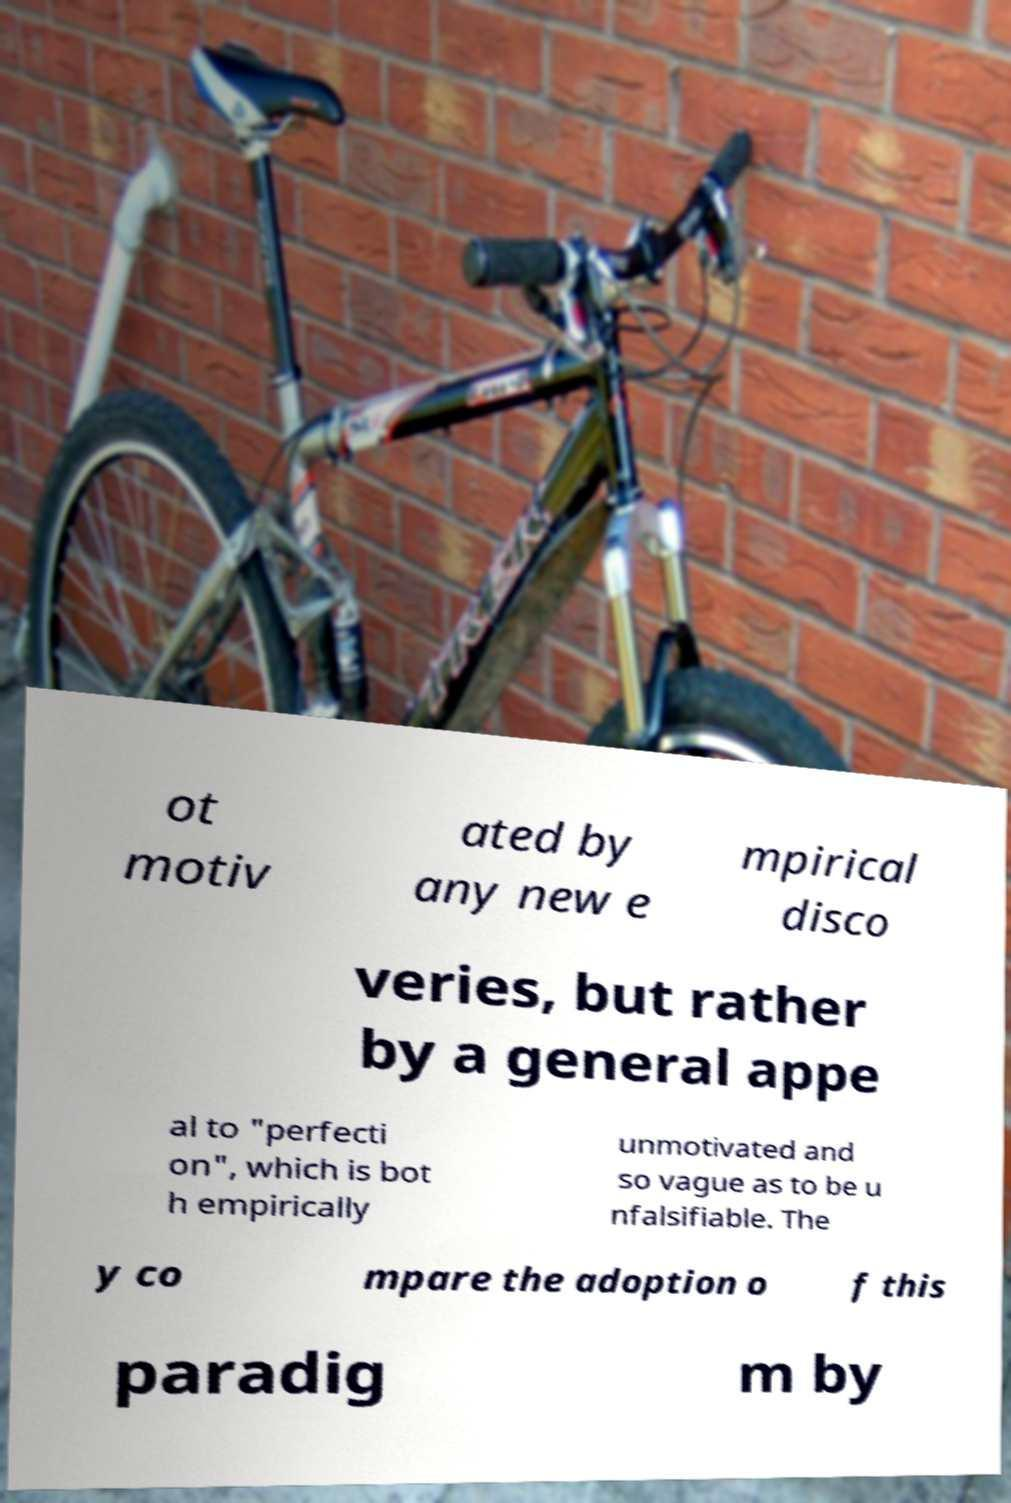Can you read and provide the text displayed in the image?This photo seems to have some interesting text. Can you extract and type it out for me? ot motiv ated by any new e mpirical disco veries, but rather by a general appe al to "perfecti on", which is bot h empirically unmotivated and so vague as to be u nfalsifiable. The y co mpare the adoption o f this paradig m by 